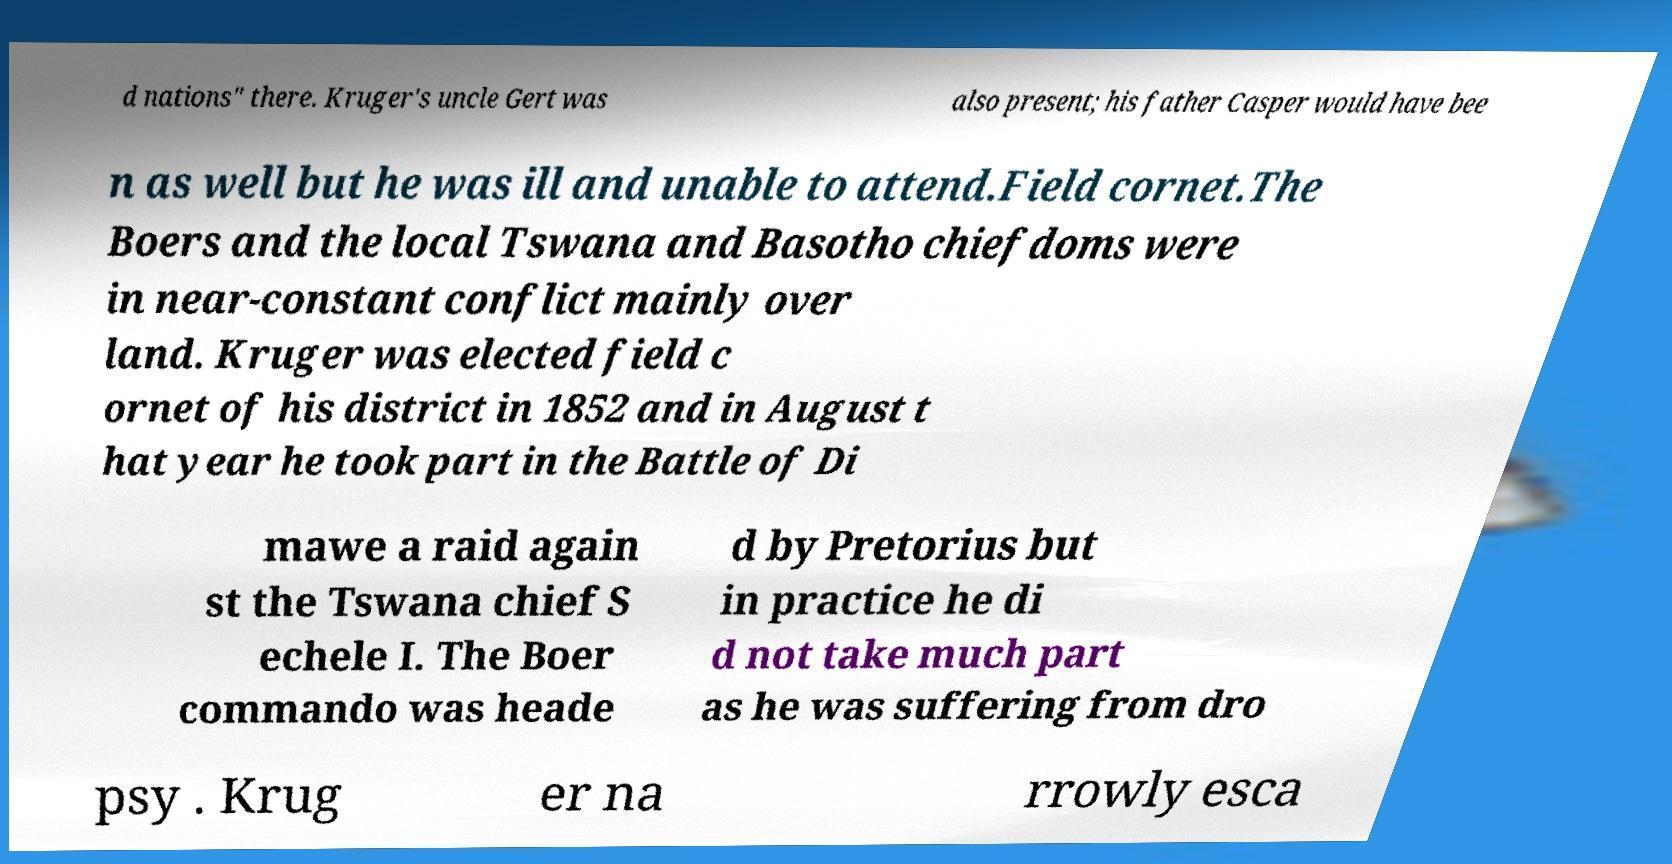There's text embedded in this image that I need extracted. Can you transcribe it verbatim? d nations" there. Kruger's uncle Gert was also present; his father Casper would have bee n as well but he was ill and unable to attend.Field cornet.The Boers and the local Tswana and Basotho chiefdoms were in near-constant conflict mainly over land. Kruger was elected field c ornet of his district in 1852 and in August t hat year he took part in the Battle of Di mawe a raid again st the Tswana chief S echele I. The Boer commando was heade d by Pretorius but in practice he di d not take much part as he was suffering from dro psy . Krug er na rrowly esca 